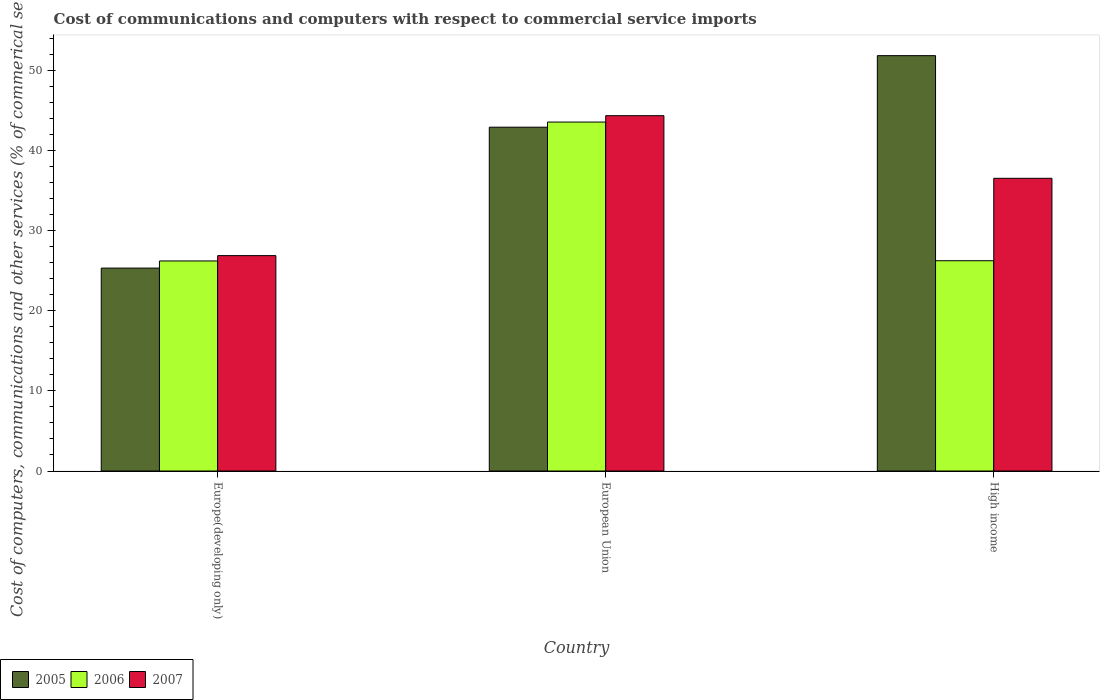How many bars are there on the 3rd tick from the left?
Your response must be concise. 3. What is the cost of communications and computers in 2005 in Europe(developing only)?
Provide a succinct answer. 25.32. Across all countries, what is the maximum cost of communications and computers in 2007?
Ensure brevity in your answer.  44.34. Across all countries, what is the minimum cost of communications and computers in 2005?
Provide a short and direct response. 25.32. In which country was the cost of communications and computers in 2007 maximum?
Your response must be concise. European Union. In which country was the cost of communications and computers in 2005 minimum?
Provide a short and direct response. Europe(developing only). What is the total cost of communications and computers in 2005 in the graph?
Provide a short and direct response. 120.05. What is the difference between the cost of communications and computers in 2006 in European Union and that in High income?
Keep it short and to the point. 17.3. What is the difference between the cost of communications and computers in 2006 in High income and the cost of communications and computers in 2007 in European Union?
Keep it short and to the point. -18.1. What is the average cost of communications and computers in 2006 per country?
Your response must be concise. 32. What is the difference between the cost of communications and computers of/in 2005 and cost of communications and computers of/in 2007 in European Union?
Provide a succinct answer. -1.44. What is the ratio of the cost of communications and computers in 2007 in Europe(developing only) to that in European Union?
Make the answer very short. 0.61. Is the cost of communications and computers in 2005 in Europe(developing only) less than that in High income?
Provide a short and direct response. Yes. Is the difference between the cost of communications and computers in 2005 in Europe(developing only) and European Union greater than the difference between the cost of communications and computers in 2007 in Europe(developing only) and European Union?
Offer a terse response. No. What is the difference between the highest and the second highest cost of communications and computers in 2006?
Your response must be concise. -0.03. What is the difference between the highest and the lowest cost of communications and computers in 2006?
Ensure brevity in your answer.  17.33. What does the 3rd bar from the left in Europe(developing only) represents?
Provide a short and direct response. 2007. Is it the case that in every country, the sum of the cost of communications and computers in 2007 and cost of communications and computers in 2006 is greater than the cost of communications and computers in 2005?
Ensure brevity in your answer.  Yes. Are all the bars in the graph horizontal?
Offer a terse response. No. How many countries are there in the graph?
Offer a very short reply. 3. What is the difference between two consecutive major ticks on the Y-axis?
Give a very brief answer. 10. How many legend labels are there?
Ensure brevity in your answer.  3. What is the title of the graph?
Offer a terse response. Cost of communications and computers with respect to commercial service imports. What is the label or title of the X-axis?
Offer a very short reply. Country. What is the label or title of the Y-axis?
Your answer should be very brief. Cost of computers, communications and other services (% of commerical service exports). What is the Cost of computers, communications and other services (% of commerical service exports) of 2005 in Europe(developing only)?
Provide a succinct answer. 25.32. What is the Cost of computers, communications and other services (% of commerical service exports) of 2006 in Europe(developing only)?
Keep it short and to the point. 26.21. What is the Cost of computers, communications and other services (% of commerical service exports) of 2007 in Europe(developing only)?
Provide a short and direct response. 26.88. What is the Cost of computers, communications and other services (% of commerical service exports) in 2005 in European Union?
Offer a very short reply. 42.9. What is the Cost of computers, communications and other services (% of commerical service exports) in 2006 in European Union?
Ensure brevity in your answer.  43.54. What is the Cost of computers, communications and other services (% of commerical service exports) of 2007 in European Union?
Your answer should be compact. 44.34. What is the Cost of computers, communications and other services (% of commerical service exports) of 2005 in High income?
Your response must be concise. 51.83. What is the Cost of computers, communications and other services (% of commerical service exports) in 2006 in High income?
Your response must be concise. 26.24. What is the Cost of computers, communications and other services (% of commerical service exports) of 2007 in High income?
Give a very brief answer. 36.52. Across all countries, what is the maximum Cost of computers, communications and other services (% of commerical service exports) in 2005?
Provide a succinct answer. 51.83. Across all countries, what is the maximum Cost of computers, communications and other services (% of commerical service exports) in 2006?
Offer a very short reply. 43.54. Across all countries, what is the maximum Cost of computers, communications and other services (% of commerical service exports) in 2007?
Your answer should be very brief. 44.34. Across all countries, what is the minimum Cost of computers, communications and other services (% of commerical service exports) in 2005?
Provide a succinct answer. 25.32. Across all countries, what is the minimum Cost of computers, communications and other services (% of commerical service exports) of 2006?
Provide a short and direct response. 26.21. Across all countries, what is the minimum Cost of computers, communications and other services (% of commerical service exports) in 2007?
Offer a terse response. 26.88. What is the total Cost of computers, communications and other services (% of commerical service exports) in 2005 in the graph?
Offer a very short reply. 120.05. What is the total Cost of computers, communications and other services (% of commerical service exports) in 2006 in the graph?
Provide a short and direct response. 95.99. What is the total Cost of computers, communications and other services (% of commerical service exports) in 2007 in the graph?
Your answer should be very brief. 107.74. What is the difference between the Cost of computers, communications and other services (% of commerical service exports) of 2005 in Europe(developing only) and that in European Union?
Provide a succinct answer. -17.58. What is the difference between the Cost of computers, communications and other services (% of commerical service exports) of 2006 in Europe(developing only) and that in European Union?
Ensure brevity in your answer.  -17.33. What is the difference between the Cost of computers, communications and other services (% of commerical service exports) in 2007 in Europe(developing only) and that in European Union?
Give a very brief answer. -17.46. What is the difference between the Cost of computers, communications and other services (% of commerical service exports) in 2005 in Europe(developing only) and that in High income?
Make the answer very short. -26.51. What is the difference between the Cost of computers, communications and other services (% of commerical service exports) in 2006 in Europe(developing only) and that in High income?
Give a very brief answer. -0.03. What is the difference between the Cost of computers, communications and other services (% of commerical service exports) in 2007 in Europe(developing only) and that in High income?
Make the answer very short. -9.65. What is the difference between the Cost of computers, communications and other services (% of commerical service exports) of 2005 in European Union and that in High income?
Your response must be concise. -8.93. What is the difference between the Cost of computers, communications and other services (% of commerical service exports) in 2006 in European Union and that in High income?
Your answer should be compact. 17.3. What is the difference between the Cost of computers, communications and other services (% of commerical service exports) in 2007 in European Union and that in High income?
Give a very brief answer. 7.81. What is the difference between the Cost of computers, communications and other services (% of commerical service exports) in 2005 in Europe(developing only) and the Cost of computers, communications and other services (% of commerical service exports) in 2006 in European Union?
Offer a very short reply. -18.22. What is the difference between the Cost of computers, communications and other services (% of commerical service exports) of 2005 in Europe(developing only) and the Cost of computers, communications and other services (% of commerical service exports) of 2007 in European Union?
Give a very brief answer. -19.02. What is the difference between the Cost of computers, communications and other services (% of commerical service exports) of 2006 in Europe(developing only) and the Cost of computers, communications and other services (% of commerical service exports) of 2007 in European Union?
Your answer should be very brief. -18.13. What is the difference between the Cost of computers, communications and other services (% of commerical service exports) in 2005 in Europe(developing only) and the Cost of computers, communications and other services (% of commerical service exports) in 2006 in High income?
Make the answer very short. -0.92. What is the difference between the Cost of computers, communications and other services (% of commerical service exports) of 2005 in Europe(developing only) and the Cost of computers, communications and other services (% of commerical service exports) of 2007 in High income?
Your response must be concise. -11.21. What is the difference between the Cost of computers, communications and other services (% of commerical service exports) in 2006 in Europe(developing only) and the Cost of computers, communications and other services (% of commerical service exports) in 2007 in High income?
Give a very brief answer. -10.31. What is the difference between the Cost of computers, communications and other services (% of commerical service exports) of 2005 in European Union and the Cost of computers, communications and other services (% of commerical service exports) of 2006 in High income?
Your response must be concise. 16.66. What is the difference between the Cost of computers, communications and other services (% of commerical service exports) in 2005 in European Union and the Cost of computers, communications and other services (% of commerical service exports) in 2007 in High income?
Give a very brief answer. 6.38. What is the difference between the Cost of computers, communications and other services (% of commerical service exports) of 2006 in European Union and the Cost of computers, communications and other services (% of commerical service exports) of 2007 in High income?
Offer a very short reply. 7.02. What is the average Cost of computers, communications and other services (% of commerical service exports) in 2005 per country?
Give a very brief answer. 40.02. What is the average Cost of computers, communications and other services (% of commerical service exports) of 2006 per country?
Give a very brief answer. 32. What is the average Cost of computers, communications and other services (% of commerical service exports) in 2007 per country?
Provide a succinct answer. 35.91. What is the difference between the Cost of computers, communications and other services (% of commerical service exports) in 2005 and Cost of computers, communications and other services (% of commerical service exports) in 2006 in Europe(developing only)?
Provide a succinct answer. -0.89. What is the difference between the Cost of computers, communications and other services (% of commerical service exports) in 2005 and Cost of computers, communications and other services (% of commerical service exports) in 2007 in Europe(developing only)?
Your answer should be compact. -1.56. What is the difference between the Cost of computers, communications and other services (% of commerical service exports) in 2006 and Cost of computers, communications and other services (% of commerical service exports) in 2007 in Europe(developing only)?
Provide a succinct answer. -0.67. What is the difference between the Cost of computers, communications and other services (% of commerical service exports) of 2005 and Cost of computers, communications and other services (% of commerical service exports) of 2006 in European Union?
Offer a very short reply. -0.64. What is the difference between the Cost of computers, communications and other services (% of commerical service exports) in 2005 and Cost of computers, communications and other services (% of commerical service exports) in 2007 in European Union?
Give a very brief answer. -1.44. What is the difference between the Cost of computers, communications and other services (% of commerical service exports) in 2006 and Cost of computers, communications and other services (% of commerical service exports) in 2007 in European Union?
Keep it short and to the point. -0.8. What is the difference between the Cost of computers, communications and other services (% of commerical service exports) in 2005 and Cost of computers, communications and other services (% of commerical service exports) in 2006 in High income?
Ensure brevity in your answer.  25.59. What is the difference between the Cost of computers, communications and other services (% of commerical service exports) in 2005 and Cost of computers, communications and other services (% of commerical service exports) in 2007 in High income?
Provide a succinct answer. 15.31. What is the difference between the Cost of computers, communications and other services (% of commerical service exports) of 2006 and Cost of computers, communications and other services (% of commerical service exports) of 2007 in High income?
Keep it short and to the point. -10.29. What is the ratio of the Cost of computers, communications and other services (% of commerical service exports) in 2005 in Europe(developing only) to that in European Union?
Your answer should be compact. 0.59. What is the ratio of the Cost of computers, communications and other services (% of commerical service exports) in 2006 in Europe(developing only) to that in European Union?
Your answer should be very brief. 0.6. What is the ratio of the Cost of computers, communications and other services (% of commerical service exports) in 2007 in Europe(developing only) to that in European Union?
Your answer should be very brief. 0.61. What is the ratio of the Cost of computers, communications and other services (% of commerical service exports) in 2005 in Europe(developing only) to that in High income?
Offer a very short reply. 0.49. What is the ratio of the Cost of computers, communications and other services (% of commerical service exports) of 2006 in Europe(developing only) to that in High income?
Offer a terse response. 1. What is the ratio of the Cost of computers, communications and other services (% of commerical service exports) of 2007 in Europe(developing only) to that in High income?
Provide a short and direct response. 0.74. What is the ratio of the Cost of computers, communications and other services (% of commerical service exports) in 2005 in European Union to that in High income?
Ensure brevity in your answer.  0.83. What is the ratio of the Cost of computers, communications and other services (% of commerical service exports) of 2006 in European Union to that in High income?
Ensure brevity in your answer.  1.66. What is the ratio of the Cost of computers, communications and other services (% of commerical service exports) of 2007 in European Union to that in High income?
Make the answer very short. 1.21. What is the difference between the highest and the second highest Cost of computers, communications and other services (% of commerical service exports) of 2005?
Your answer should be very brief. 8.93. What is the difference between the highest and the second highest Cost of computers, communications and other services (% of commerical service exports) of 2006?
Give a very brief answer. 17.3. What is the difference between the highest and the second highest Cost of computers, communications and other services (% of commerical service exports) of 2007?
Make the answer very short. 7.81. What is the difference between the highest and the lowest Cost of computers, communications and other services (% of commerical service exports) in 2005?
Offer a terse response. 26.51. What is the difference between the highest and the lowest Cost of computers, communications and other services (% of commerical service exports) in 2006?
Give a very brief answer. 17.33. What is the difference between the highest and the lowest Cost of computers, communications and other services (% of commerical service exports) in 2007?
Ensure brevity in your answer.  17.46. 